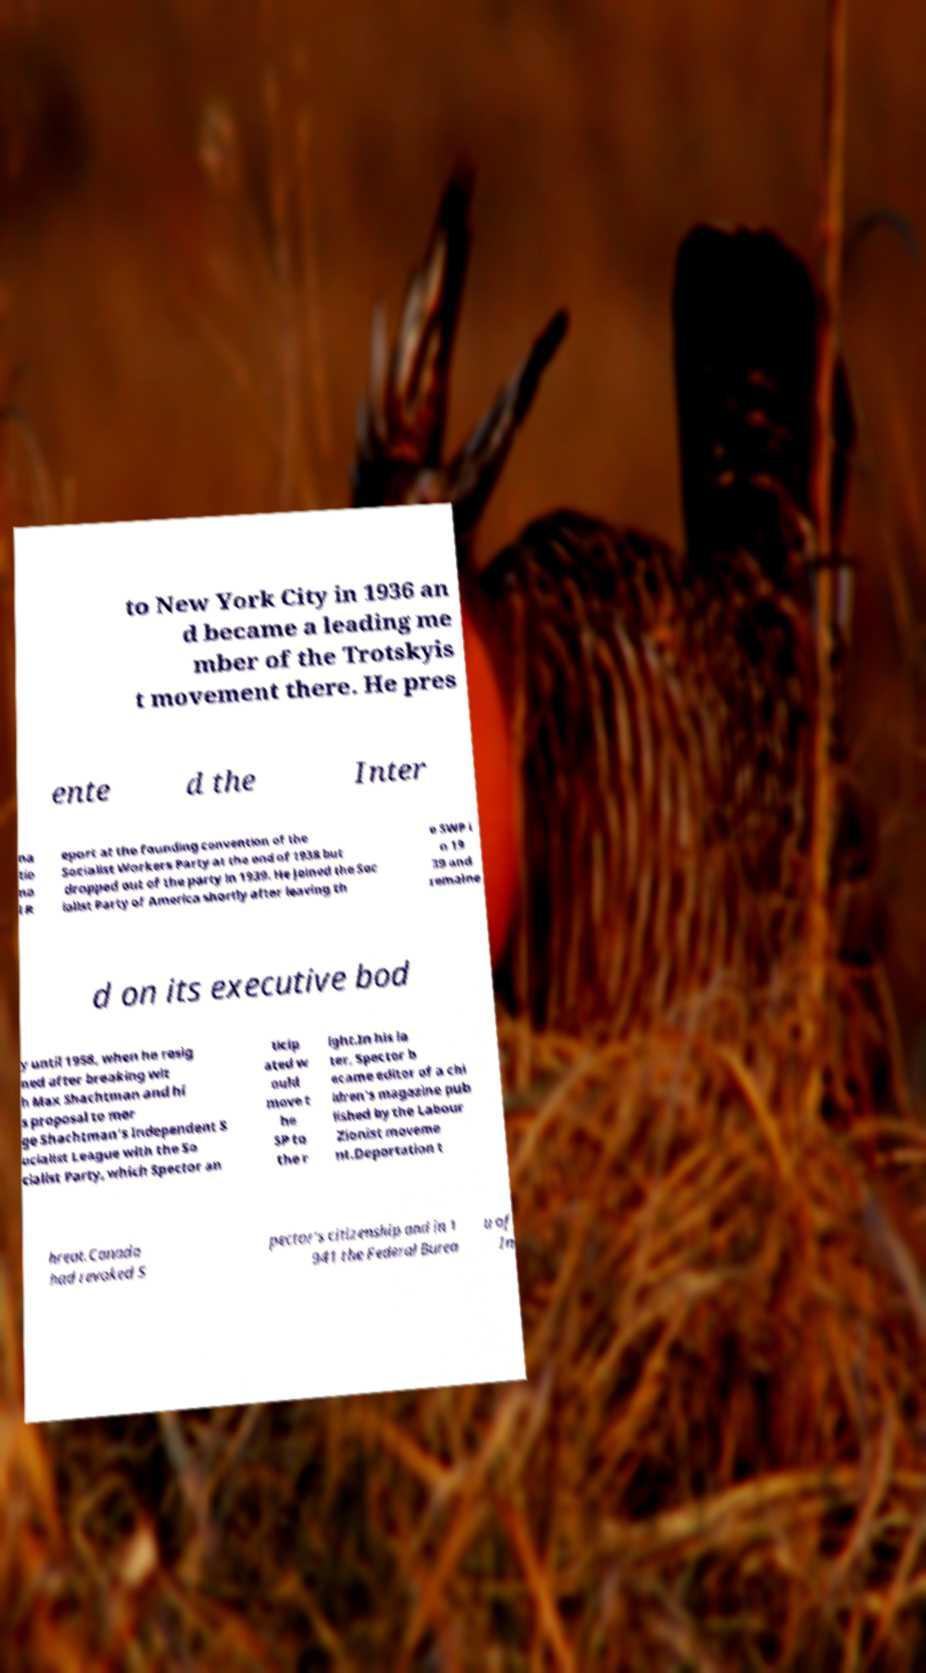What messages or text are displayed in this image? I need them in a readable, typed format. to New York City in 1936 an d became a leading me mber of the Trotskyis t movement there. He pres ente d the Inter na tio na l R eport at the founding convention of the Socialist Workers Party at the end of 1938 but dropped out of the party in 1939. He joined the Soc ialist Party of America shortly after leaving th e SWP i n 19 39 and remaine d on its executive bod y until 1958, when he resig ned after breaking wit h Max Shachtman and hi s proposal to mer ge Shachtman's Independent S ocialist League with the So cialist Party, which Spector an ticip ated w ould move t he SP to the r ight.In his la ter, Spector b ecame editor of a chi ldren's magazine pub lished by the Labour Zionist moveme nt.Deportation t hreat.Canada had revoked S pector's citizenship and in 1 941 the Federal Burea u of In 